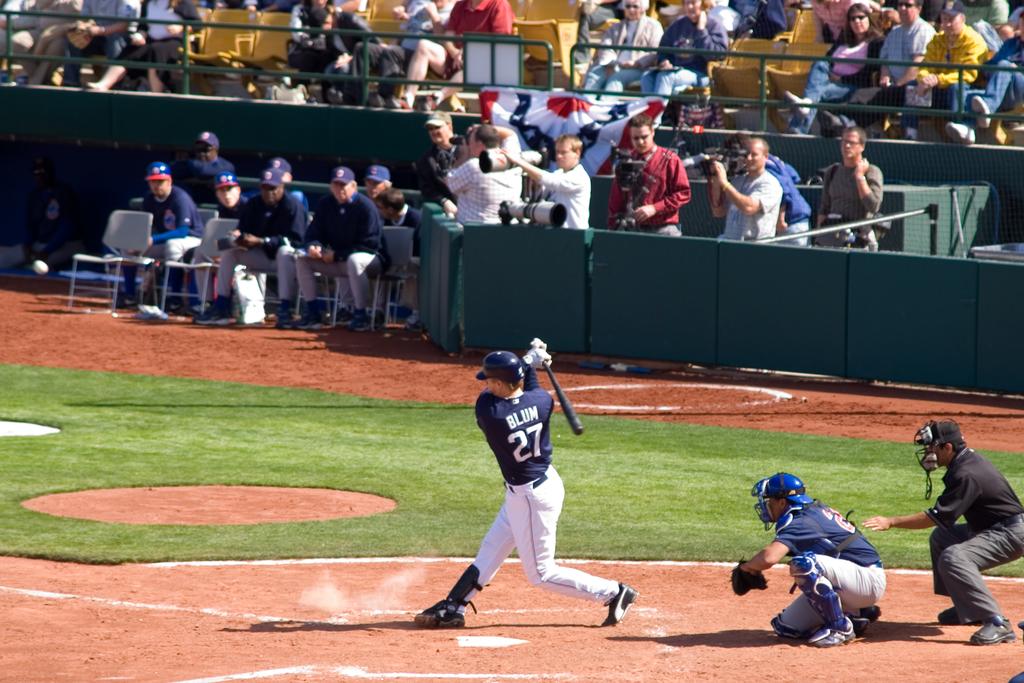What is the batter's last name?
Make the answer very short. Blum. What number does the batter wear?
Provide a short and direct response. 27. 